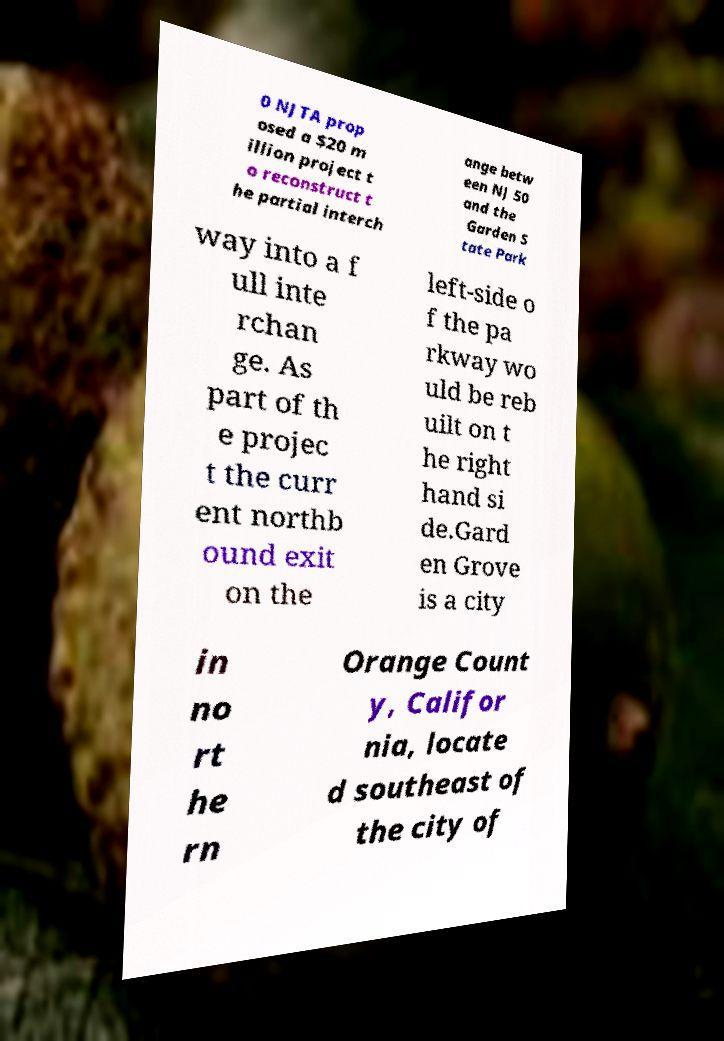Can you accurately transcribe the text from the provided image for me? 0 NJTA prop osed a $20 m illion project t o reconstruct t he partial interch ange betw een NJ 50 and the Garden S tate Park way into a f ull inte rchan ge. As part of th e projec t the curr ent northb ound exit on the left-side o f the pa rkway wo uld be reb uilt on t he right hand si de.Gard en Grove is a city in no rt he rn Orange Count y, Califor nia, locate d southeast of the city of 